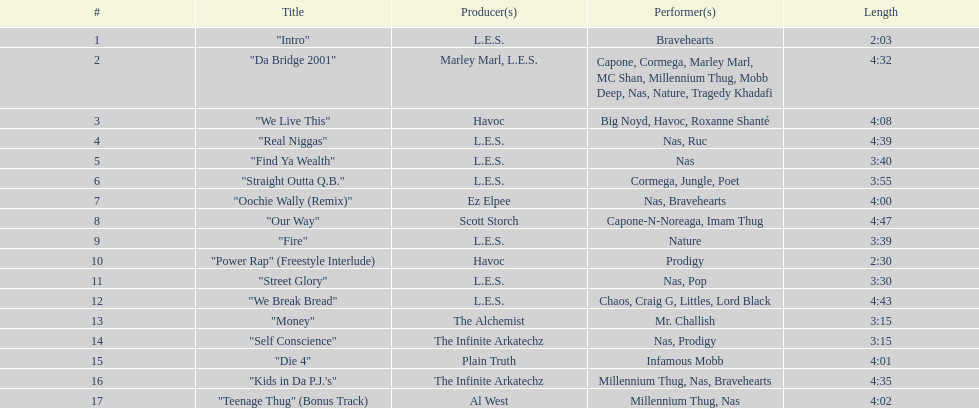Which is more extended, fire or die 4? "Die 4". 